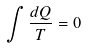<formula> <loc_0><loc_0><loc_500><loc_500>\int \frac { d Q } { T } = 0</formula> 